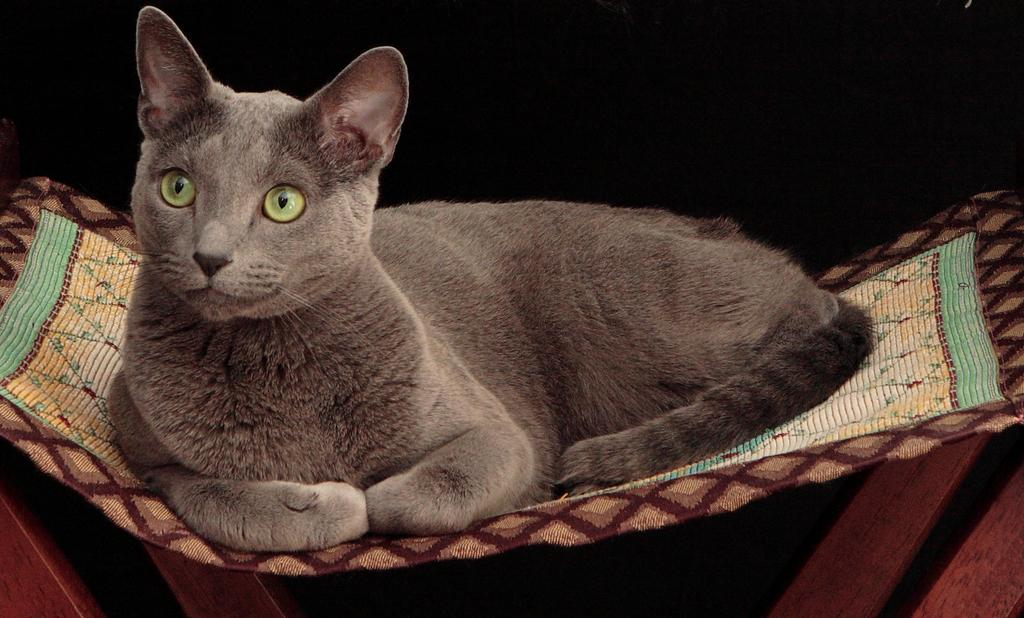What type of animal is in the image? There is a cat in the image. What is the cat sitting on? The cat is sitting on a cloth. Where is the ant in the image? There is no ant present in the image. What type of dinner is being served in the image? There is no dinner present in the image. 